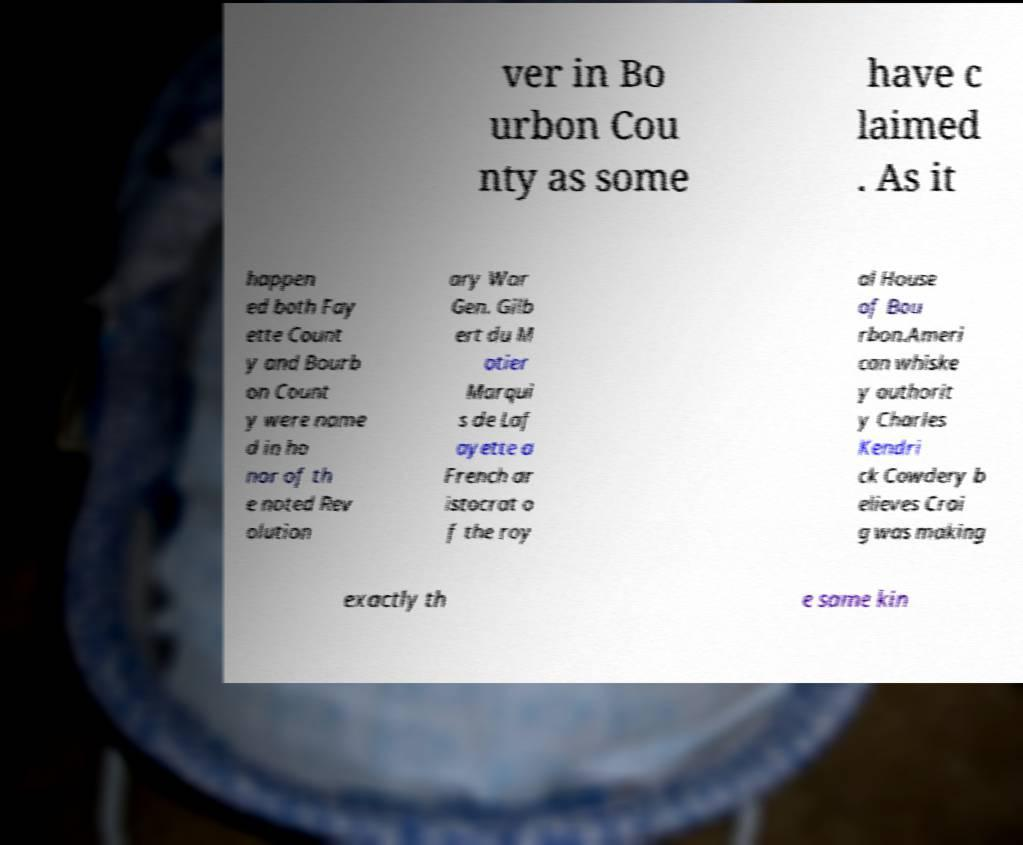There's text embedded in this image that I need extracted. Can you transcribe it verbatim? ver in Bo urbon Cou nty as some have c laimed . As it happen ed both Fay ette Count y and Bourb on Count y were name d in ho nor of th e noted Rev olution ary War Gen. Gilb ert du M otier Marqui s de Laf ayette a French ar istocrat o f the roy al House of Bou rbon.Ameri can whiske y authorit y Charles Kendri ck Cowdery b elieves Crai g was making exactly th e same kin 